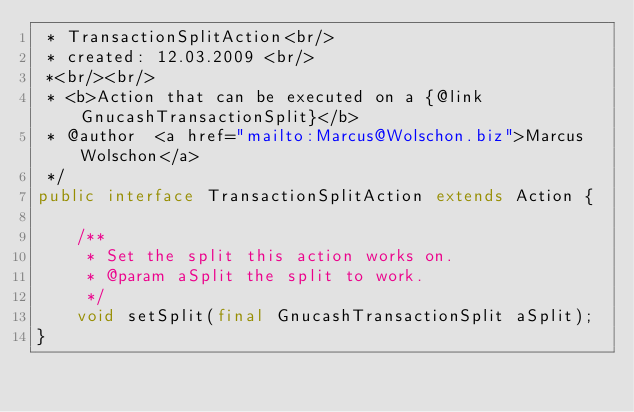Convert code to text. <code><loc_0><loc_0><loc_500><loc_500><_Java_> * TransactionSplitAction<br/>
 * created: 12.03.2009 <br/>
 *<br/><br/>
 * <b>Action that can be executed on a {@link GnucashTransactionSplit}</b>
 * @author  <a href="mailto:Marcus@Wolschon.biz">Marcus Wolschon</a>
 */
public interface TransactionSplitAction extends Action {

    /**
     * Set the split this action works on.
     * @param aSplit the split to work.
     */
    void setSplit(final GnucashTransactionSplit aSplit);
}
</code> 